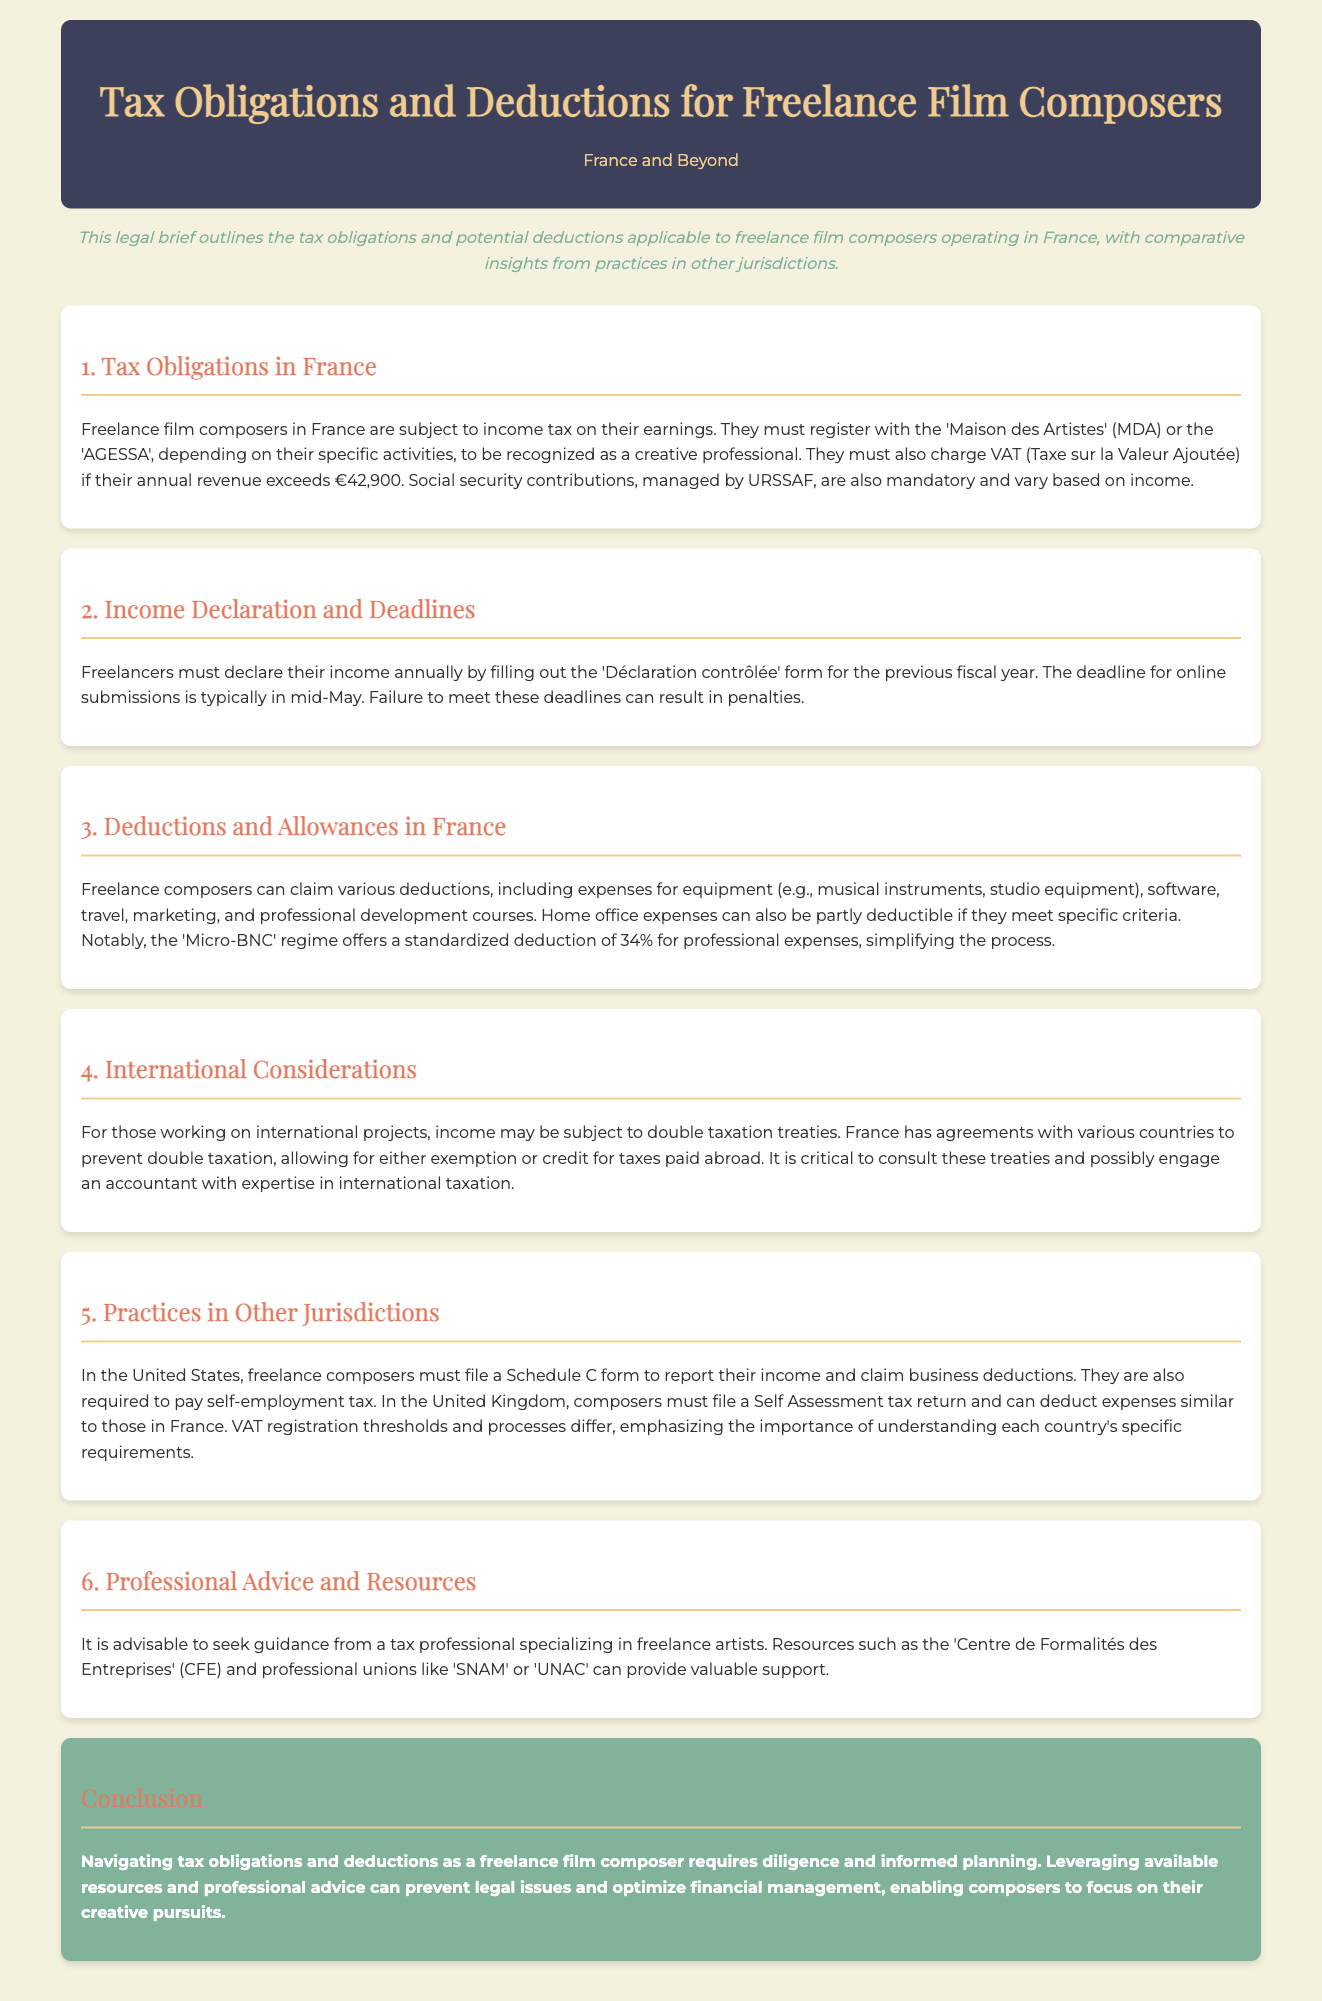What is the VAT threshold for freelance composers in France? The document states that freelance composers must charge VAT if their annual revenue exceeds €42,900.
Answer: €42,900 What form must freelancers fill out to declare their income? The legal brief mentions that freelancers must fill out the 'Déclaration contrôlée' form for income declaration.
Answer: 'Déclaration contrôlée' What is the standardized deduction percentage under the 'Micro-BNC' regime? The document notes that the 'Micro-BNC' regime offers a standardized deduction of 34% for professional expenses.
Answer: 34% Which organization must composers register with in France? The brief indicates that composers must register with either the 'Maison des Artistes' (MDA) or the 'AGESSA'.
Answer: 'Maison des Artistes' or 'AGESSA' What is a critical factor for international income taxation? The document highlights that income may be subject to double taxation treaties.
Answer: Double taxation treaties What type of tax must freelancers in the United States pay? The section on practices in other jurisdictions states that freelance composers in the U.S. must pay self-employment tax.
Answer: Self-employment tax What type of professional is recommended for tax guidance? The brief advises seeking guidance from a tax professional specializing in freelance artists.
Answer: Tax professional What is the main purpose of consulting treaties when working internationally? The document explains that consulting treaties allows for either exemption or credit for taxes paid abroad.
Answer: Exemption or credit for taxes paid abroad 